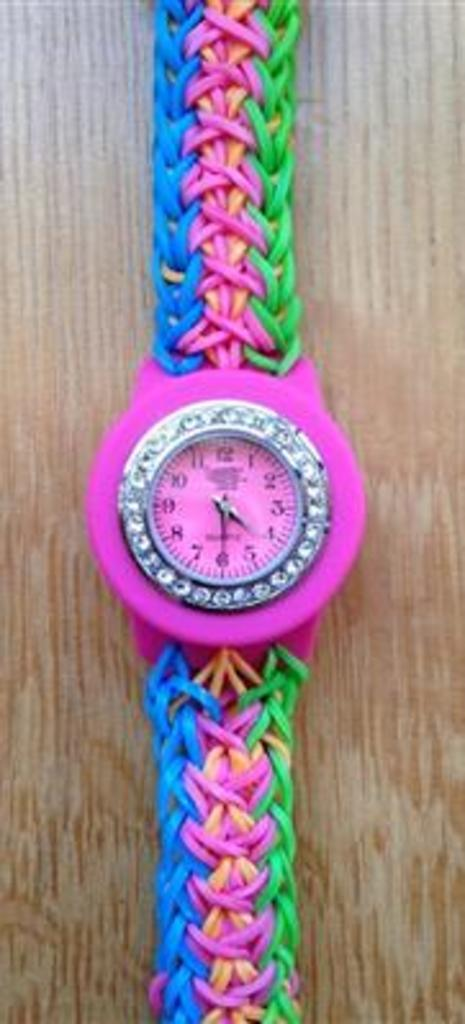Provide a one-sentence caption for the provided image. Colorful stopwatch with the hands set at 4 and 6. 